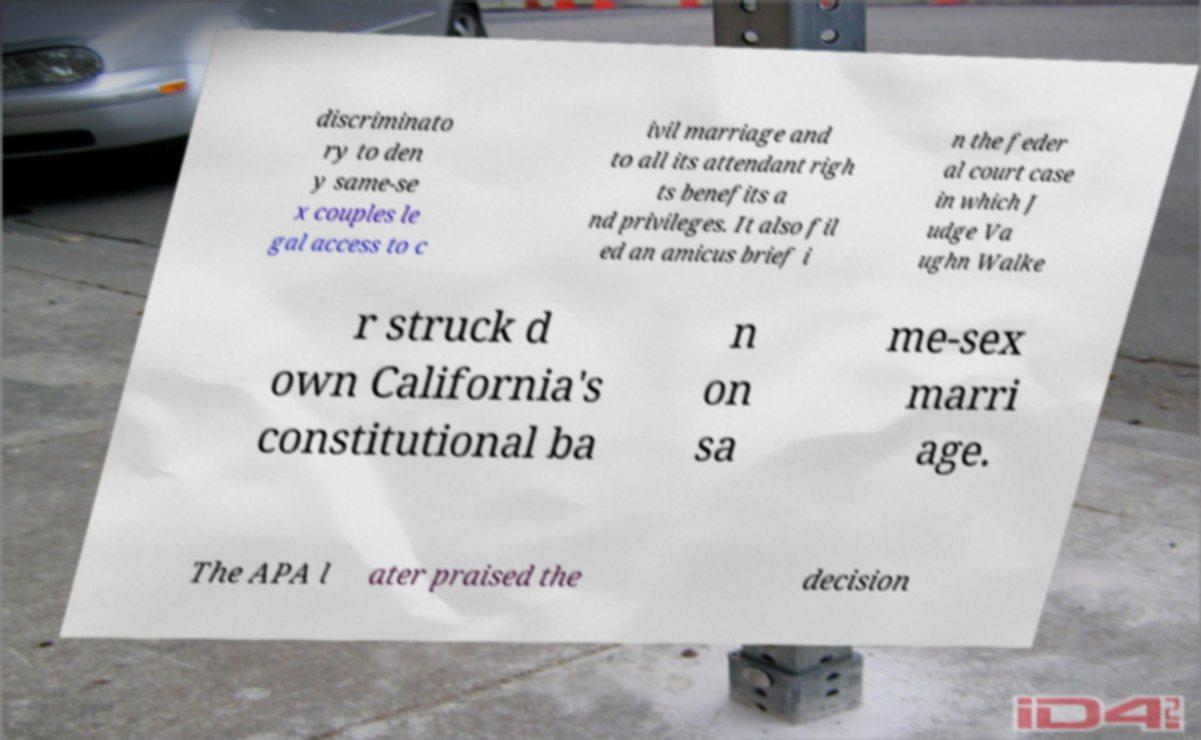Please read and relay the text visible in this image. What does it say? discriminato ry to den y same-se x couples le gal access to c ivil marriage and to all its attendant righ ts benefits a nd privileges. It also fil ed an amicus brief i n the feder al court case in which J udge Va ughn Walke r struck d own California's constitutional ba n on sa me-sex marri age. The APA l ater praised the decision 